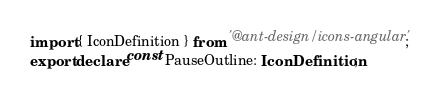<code> <loc_0><loc_0><loc_500><loc_500><_TypeScript_>import { IconDefinition } from '@ant-design/icons-angular';
export declare const PauseOutline: IconDefinition;
</code> 